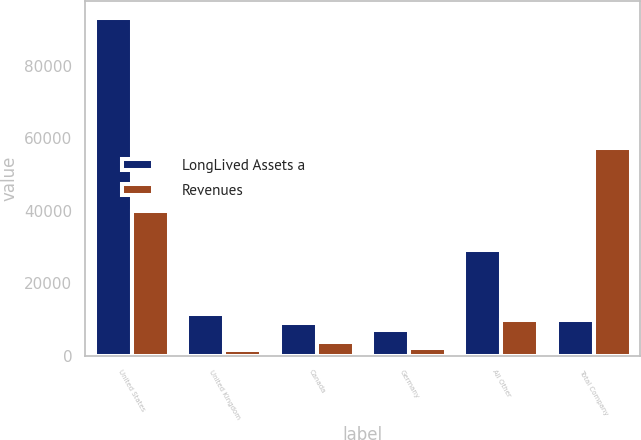Convert chart to OTSL. <chart><loc_0><loc_0><loc_500><loc_500><stacked_bar_chart><ecel><fcel>United States<fcel>United Kingdom<fcel>Canada<fcel>Germany<fcel>All Other<fcel>Total Company<nl><fcel>LongLived Assets a<fcel>93142<fcel>11451<fcel>8978<fcel>6950<fcel>29037<fcel>9896<nl><fcel>Revenues<fcel>39853<fcel>1490<fcel>3814<fcel>2203<fcel>9896<fcel>57256<nl></chart> 